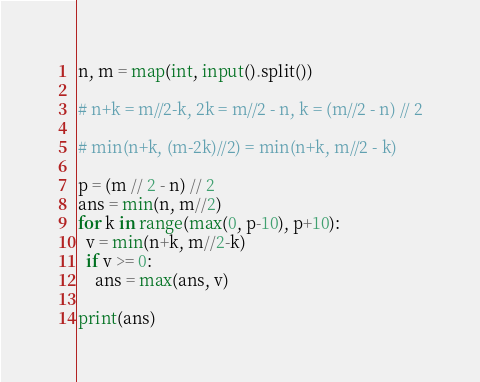<code> <loc_0><loc_0><loc_500><loc_500><_Python_>n, m = map(int, input().split())

# n+k = m//2-k, 2k = m//2 - n, k = (m//2 - n) // 2

# min(n+k, (m-2k)//2) = min(n+k, m//2 - k)

p = (m // 2 - n) // 2
ans = min(n, m//2)
for k in range(max(0, p-10), p+10):
  v = min(n+k, m//2-k)
  if v >= 0:
    ans = max(ans, v)
  
print(ans)</code> 